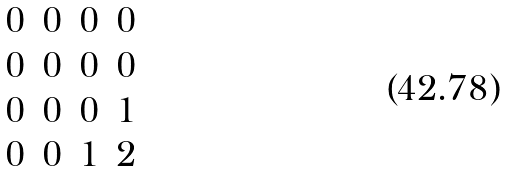<formula> <loc_0><loc_0><loc_500><loc_500>\begin{matrix} 0 & 0 & 0 & 0 \\ 0 & 0 & 0 & 0 \\ 0 & 0 & 0 & 1 \\ 0 & 0 & 1 & 2 \end{matrix}</formula> 